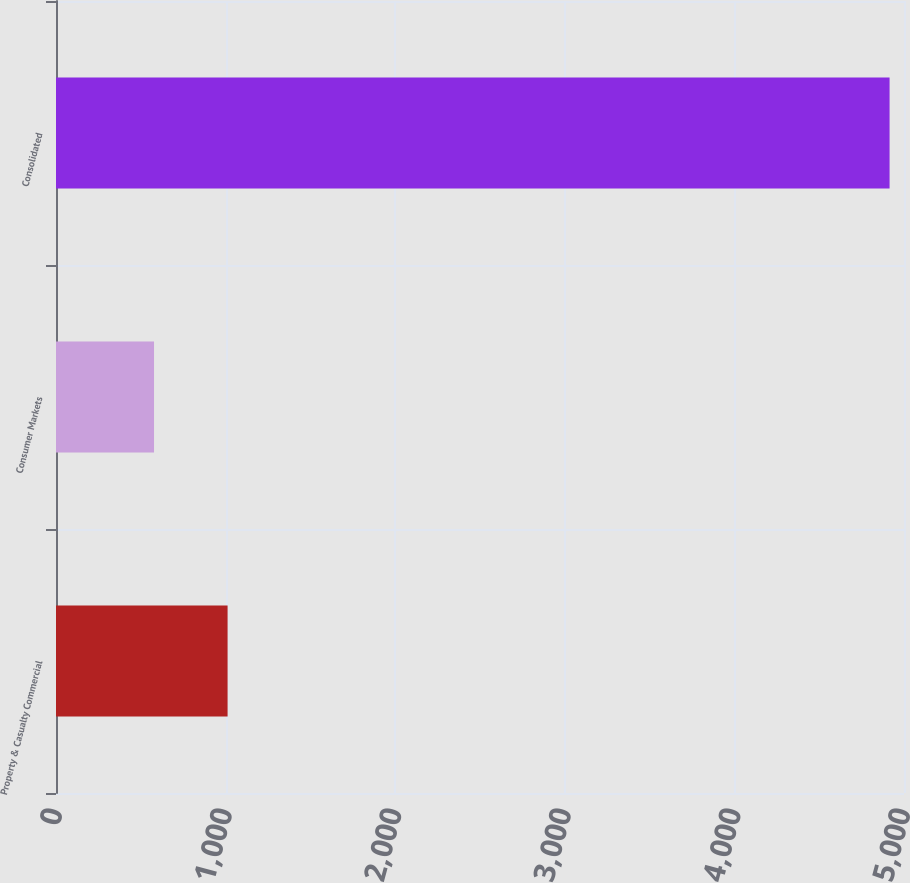Convert chart. <chart><loc_0><loc_0><loc_500><loc_500><bar_chart><fcel>Property & Casualty Commercial<fcel>Consumer Markets<fcel>Consolidated<nl><fcel>1011.7<fcel>578<fcel>4915<nl></chart> 